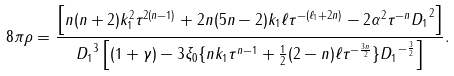<formula> <loc_0><loc_0><loc_500><loc_500>8 \pi \rho = \frac { \left [ n ( n + 2 ) k ^ { 2 } _ { 1 } \tau ^ { 2 ( n - 1 ) } + 2 n ( 5 n - 2 ) k _ { 1 } \ell \tau ^ { - ( \ell _ { 1 } + 2 n ) } - 2 \alpha ^ { 2 } \tau ^ { - n } { D _ { 1 } } ^ { 2 } \right ] } { { D _ { 1 } } ^ { 3 } \left [ ( 1 + \gamma ) - 3 \xi _ { 0 } \{ n k _ { 1 } \tau ^ { n - 1 } + \frac { 1 } { 2 } ( 2 - n ) \ell \tau ^ { - \frac { 3 n } { 2 } } \} { D _ { 1 } } ^ { - \frac { 3 } { 2 } } \right ] } .</formula> 